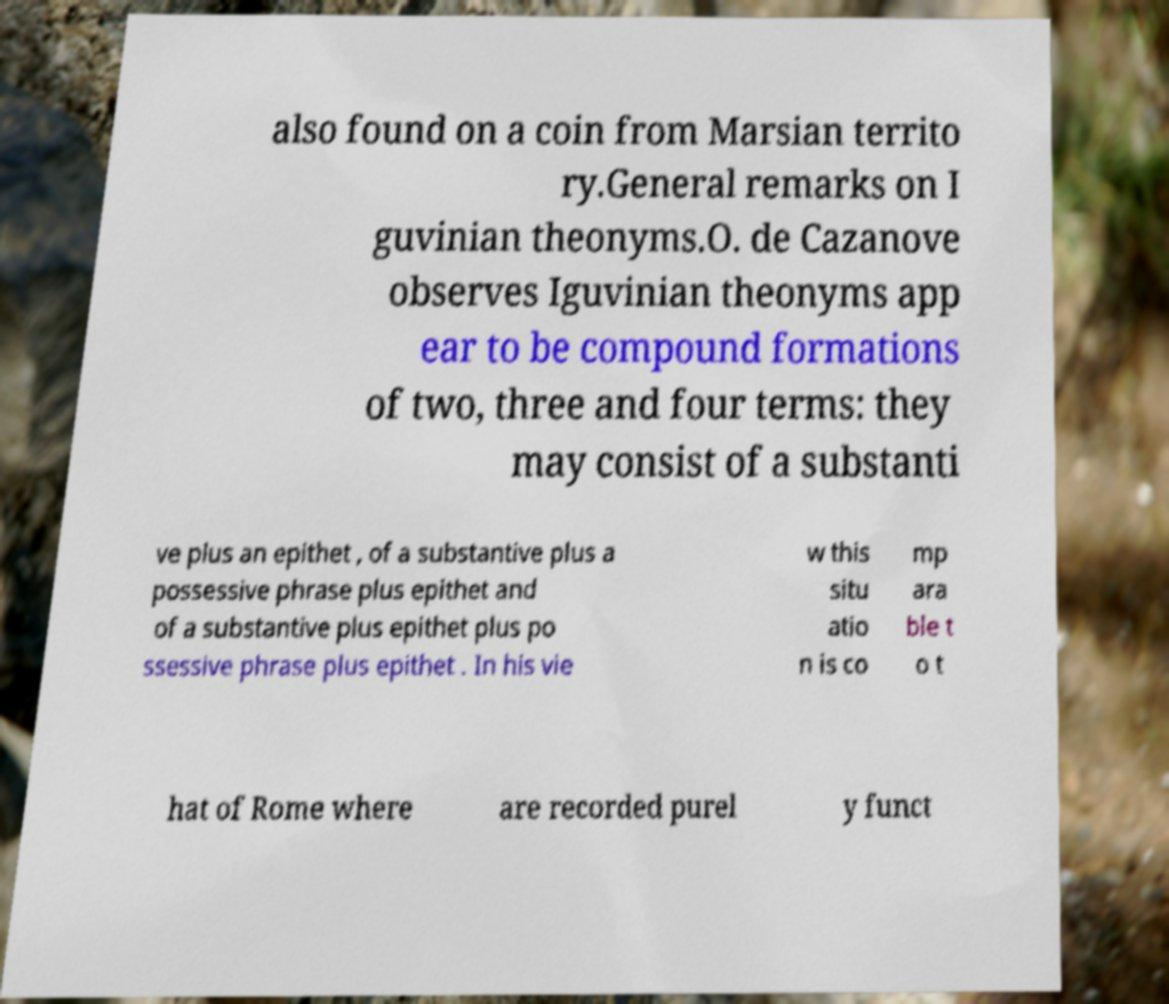Could you extract and type out the text from this image? also found on a coin from Marsian territo ry.General remarks on I guvinian theonyms.O. de Cazanove observes Iguvinian theonyms app ear to be compound formations of two, three and four terms: they may consist of a substanti ve plus an epithet , of a substantive plus a possessive phrase plus epithet and of a substantive plus epithet plus po ssessive phrase plus epithet . In his vie w this situ atio n is co mp ara ble t o t hat of Rome where are recorded purel y funct 